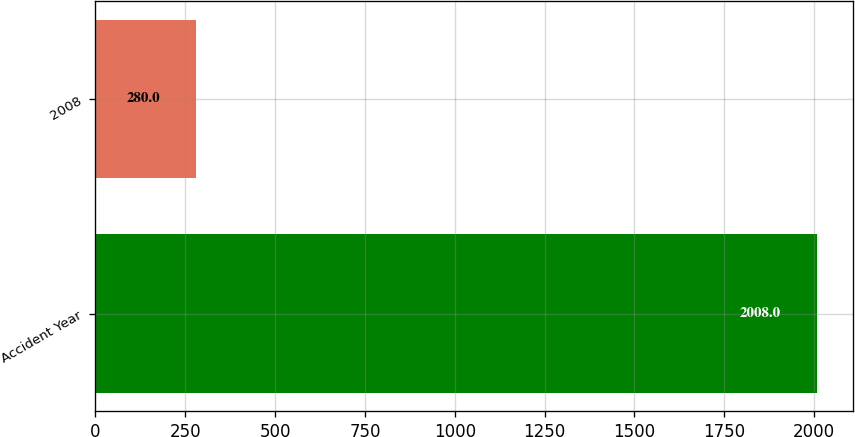Convert chart to OTSL. <chart><loc_0><loc_0><loc_500><loc_500><bar_chart><fcel>Accident Year<fcel>2008<nl><fcel>2008<fcel>280<nl></chart> 